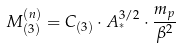Convert formula to latex. <formula><loc_0><loc_0><loc_500><loc_500>M _ { ( 3 ) } ^ { ( n ) } = C _ { ( 3 ) } \cdot A _ { ^ { * } } ^ { 3 / 2 } \cdot \frac { m _ { p } } { \beta ^ { 2 } }</formula> 